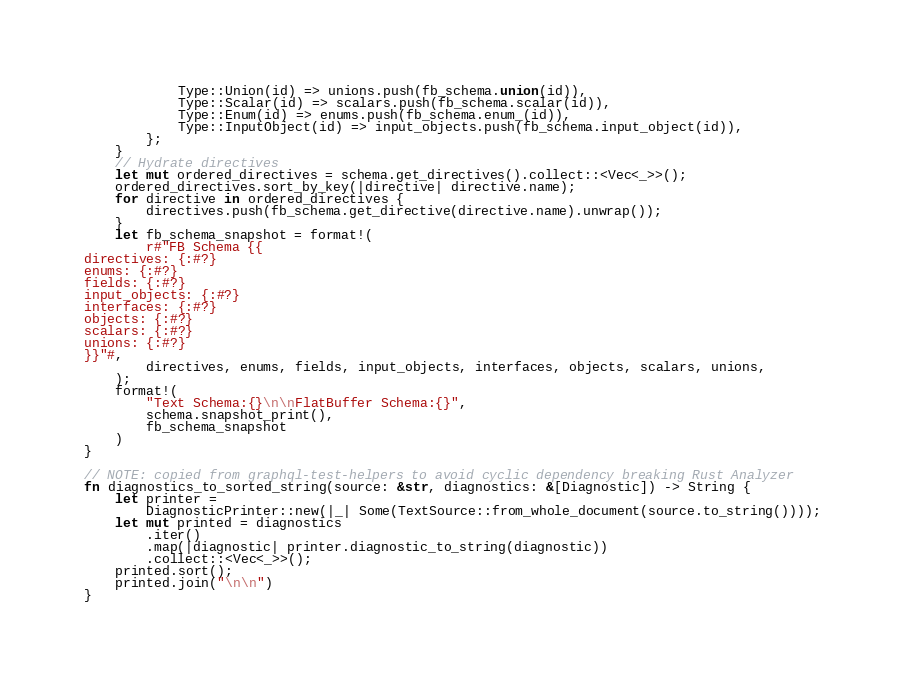Convert code to text. <code><loc_0><loc_0><loc_500><loc_500><_Rust_>            Type::Union(id) => unions.push(fb_schema.union(id)),
            Type::Scalar(id) => scalars.push(fb_schema.scalar(id)),
            Type::Enum(id) => enums.push(fb_schema.enum_(id)),
            Type::InputObject(id) => input_objects.push(fb_schema.input_object(id)),
        };
    }
    // Hydrate directives
    let mut ordered_directives = schema.get_directives().collect::<Vec<_>>();
    ordered_directives.sort_by_key(|directive| directive.name);
    for directive in ordered_directives {
        directives.push(fb_schema.get_directive(directive.name).unwrap());
    }
    let fb_schema_snapshot = format!(
        r#"FB Schema {{
directives: {:#?}
enums: {:#?}
fields: {:#?}
input_objects: {:#?}
interfaces: {:#?}
objects: {:#?}
scalars: {:#?}
unions: {:#?}
}}"#,
        directives, enums, fields, input_objects, interfaces, objects, scalars, unions,
    );
    format!(
        "Text Schema:{}\n\nFlatBuffer Schema:{}",
        schema.snapshot_print(),
        fb_schema_snapshot
    )
}

// NOTE: copied from graphql-test-helpers to avoid cyclic dependency breaking Rust Analyzer
fn diagnostics_to_sorted_string(source: &str, diagnostics: &[Diagnostic]) -> String {
    let printer =
        DiagnosticPrinter::new(|_| Some(TextSource::from_whole_document(source.to_string())));
    let mut printed = diagnostics
        .iter()
        .map(|diagnostic| printer.diagnostic_to_string(diagnostic))
        .collect::<Vec<_>>();
    printed.sort();
    printed.join("\n\n")
}
</code> 